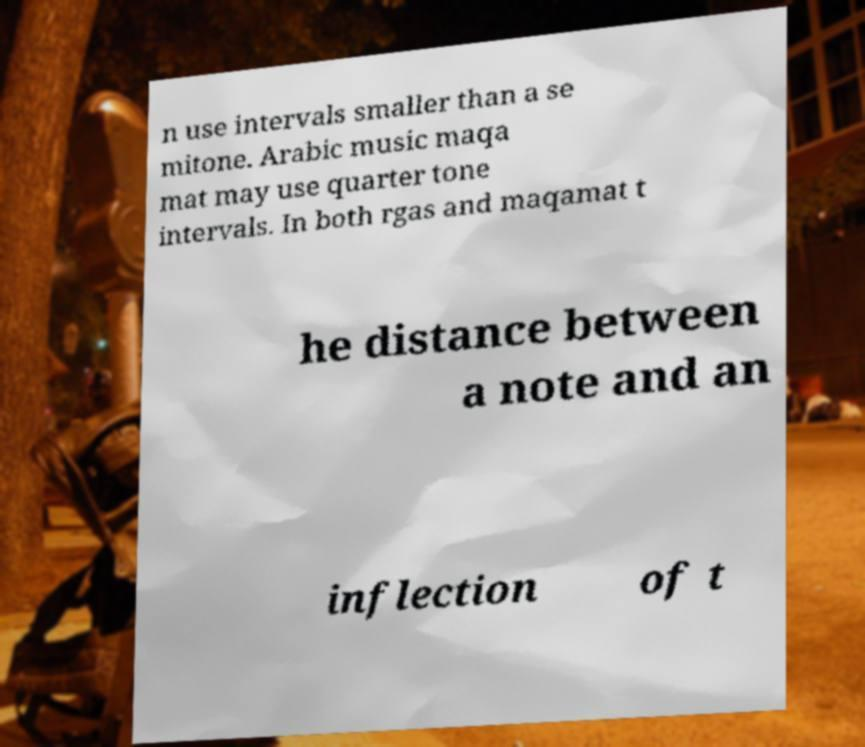What messages or text are displayed in this image? I need them in a readable, typed format. n use intervals smaller than a se mitone. Arabic music maqa mat may use quarter tone intervals. In both rgas and maqamat t he distance between a note and an inflection of t 